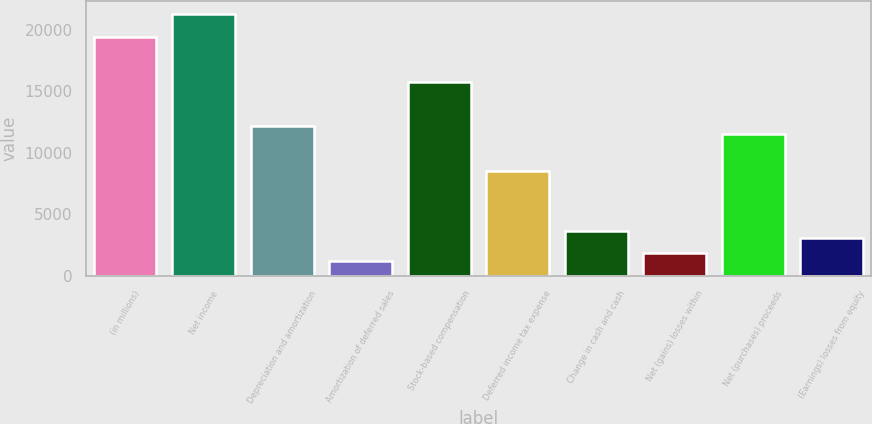Convert chart. <chart><loc_0><loc_0><loc_500><loc_500><bar_chart><fcel>(in millions)<fcel>Net income<fcel>Depreciation and amortization<fcel>Amortization of deferred sales<fcel>Stock-based compensation<fcel>Deferred income tax expense<fcel>Change in cash and cash<fcel>Net (gains) losses within<fcel>Net (purchases) proceeds<fcel>(Earnings) losses from equity<nl><fcel>19434.8<fcel>21255.5<fcel>12152<fcel>1227.8<fcel>15793.4<fcel>8510.6<fcel>3655.4<fcel>1834.7<fcel>11545.1<fcel>3048.5<nl></chart> 